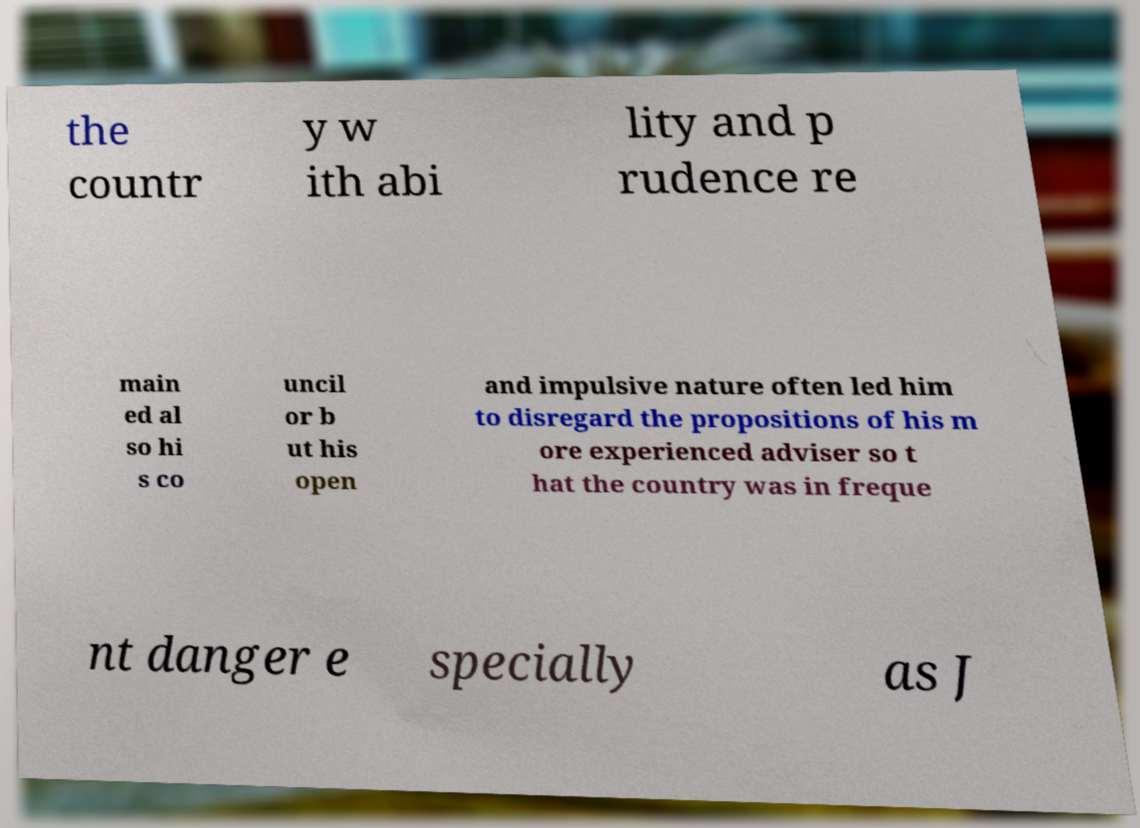Please identify and transcribe the text found in this image. the countr y w ith abi lity and p rudence re main ed al so hi s co uncil or b ut his open and impulsive nature often led him to disregard the propositions of his m ore experienced adviser so t hat the country was in freque nt danger e specially as J 